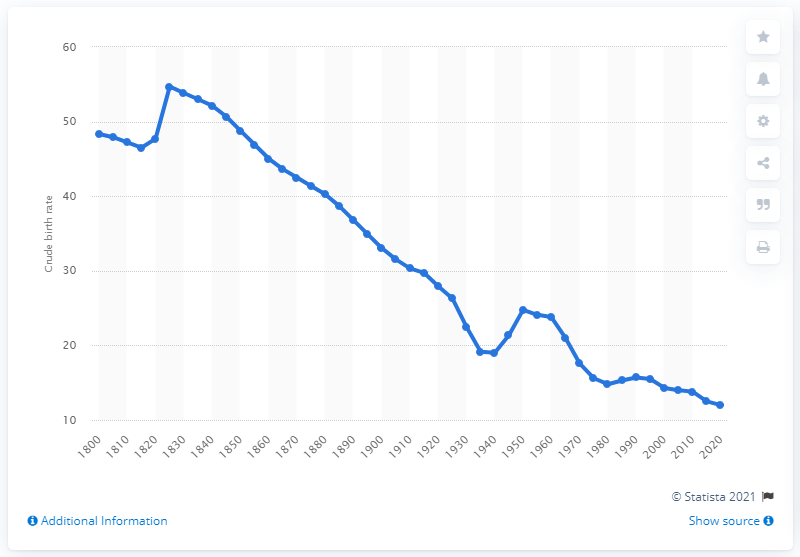Identify some key points in this picture. The birth rate in 1955 was 24.1%. 